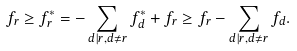<formula> <loc_0><loc_0><loc_500><loc_500>f _ { r } \geq f ^ { * } _ { r } = - \sum _ { d | r , d \neq r } f ^ { * } _ { d } + f _ { r } \geq f _ { r } - \sum _ { d | r , d \neq r } f _ { d } .</formula> 